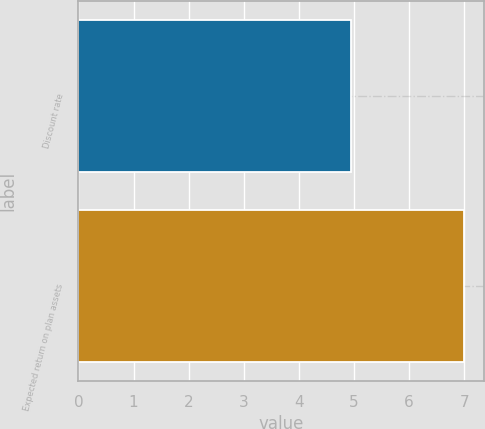<chart> <loc_0><loc_0><loc_500><loc_500><bar_chart><fcel>Discount rate<fcel>Expected return on plan assets<nl><fcel>4.95<fcel>7<nl></chart> 